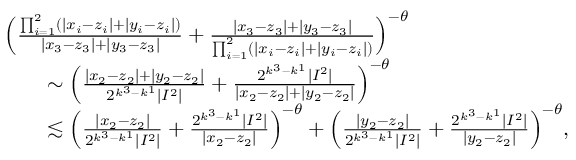<formula> <loc_0><loc_0><loc_500><loc_500>\begin{array} { r l } & { \left ( \frac { \prod _ { i = 1 } ^ { 2 } ( | x _ { i } - z _ { i } | + | y _ { i } - z _ { i } | ) } { | x _ { 3 } - z _ { 3 } | + | y _ { 3 } - z _ { 3 } | } + \frac { | x _ { 3 } - z _ { 3 } | + | y _ { 3 } - z _ { 3 } | } { \prod _ { i = 1 } ^ { 2 } ( | x _ { i } - z _ { i } | + | y _ { i } - z _ { i } | ) } \right ) ^ { - \theta } } \\ & { \quad \sim \left ( \frac { | x _ { 2 } - z _ { 2 } | + | y _ { 2 } - z _ { 2 } | } { 2 ^ { k ^ { 3 } - k ^ { 1 } } | I ^ { 2 } | } + \frac { 2 ^ { k ^ { 3 } - k ^ { 1 } } | I ^ { 2 } | } { | x _ { 2 } - z _ { 2 } | + | y _ { 2 } - z _ { 2 } | } \right ) ^ { - \theta } } \\ & { \quad \lesssim \left ( \frac { | x _ { 2 } - z _ { 2 } | } { 2 ^ { k ^ { 3 } - k ^ { 1 } } | I ^ { 2 } | } + \frac { 2 ^ { k ^ { 3 } - k ^ { 1 } } | I ^ { 2 } | } { | x _ { 2 } - z _ { 2 } | } \right ) ^ { - \theta } + \left ( \frac { | y _ { 2 } - z _ { 2 } | } { 2 ^ { k ^ { 3 } - k ^ { 1 } } | I ^ { 2 } | } + \frac { 2 ^ { k ^ { 3 } - k ^ { 1 } } | I ^ { 2 } | } { | y _ { 2 } - z _ { 2 } | } \right ) ^ { - \theta } , } \end{array}</formula> 